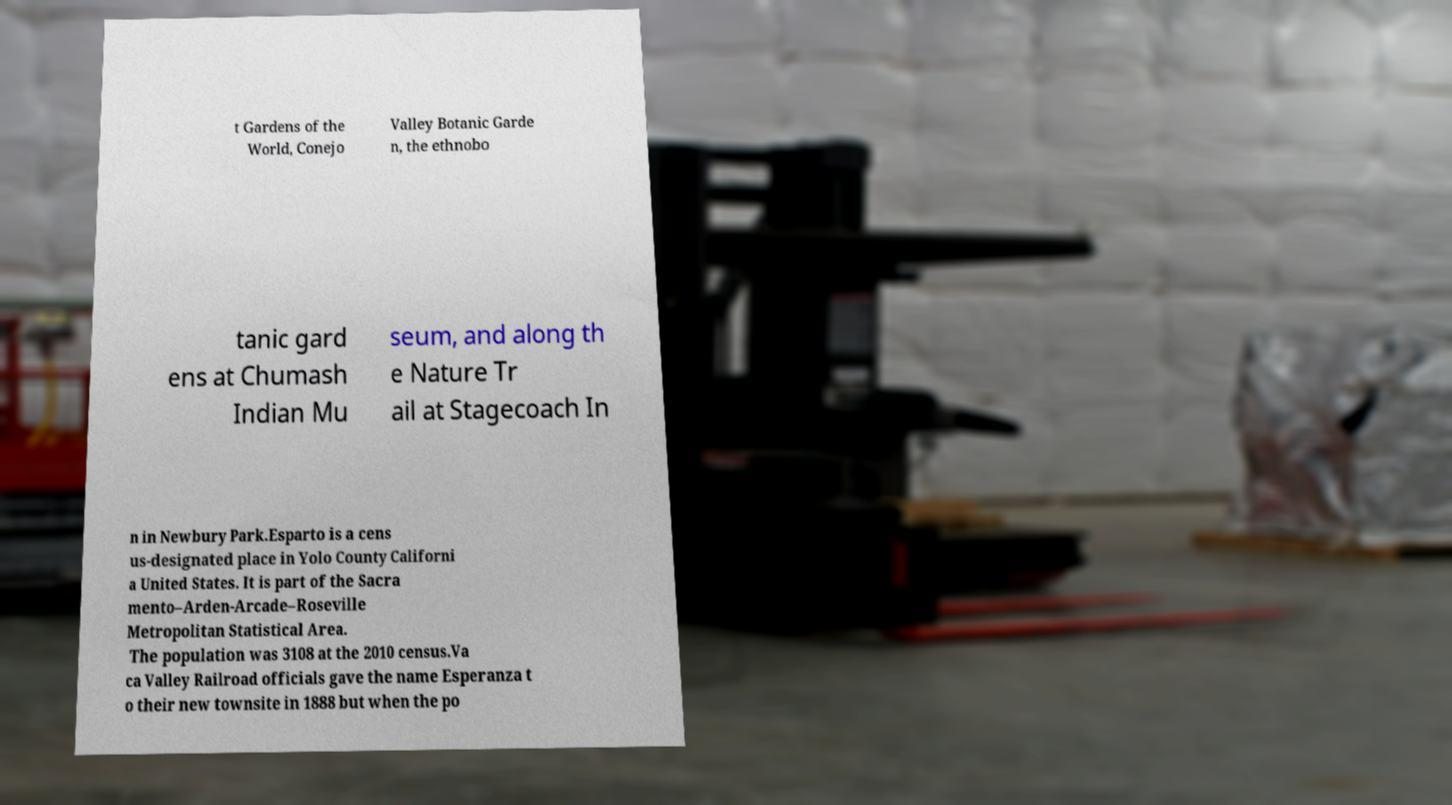Could you extract and type out the text from this image? t Gardens of the World, Conejo Valley Botanic Garde n, the ethnobo tanic gard ens at Chumash Indian Mu seum, and along th e Nature Tr ail at Stagecoach In n in Newbury Park.Esparto is a cens us-designated place in Yolo County Californi a United States. It is part of the Sacra mento–Arden-Arcade–Roseville Metropolitan Statistical Area. The population was 3108 at the 2010 census.Va ca Valley Railroad officials gave the name Esperanza t o their new townsite in 1888 but when the po 